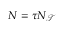Convert formula to latex. <formula><loc_0><loc_0><loc_500><loc_500>N = \tau N _ { \mathcal { T } }</formula> 